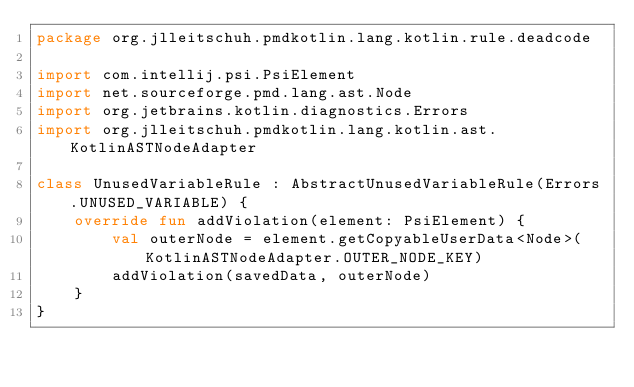Convert code to text. <code><loc_0><loc_0><loc_500><loc_500><_Kotlin_>package org.jlleitschuh.pmdkotlin.lang.kotlin.rule.deadcode

import com.intellij.psi.PsiElement
import net.sourceforge.pmd.lang.ast.Node
import org.jetbrains.kotlin.diagnostics.Errors
import org.jlleitschuh.pmdkotlin.lang.kotlin.ast.KotlinASTNodeAdapter

class UnusedVariableRule : AbstractUnusedVariableRule(Errors.UNUSED_VARIABLE) {
    override fun addViolation(element: PsiElement) {
        val outerNode = element.getCopyableUserData<Node>(KotlinASTNodeAdapter.OUTER_NODE_KEY)
        addViolation(savedData, outerNode)
    }
}
</code> 